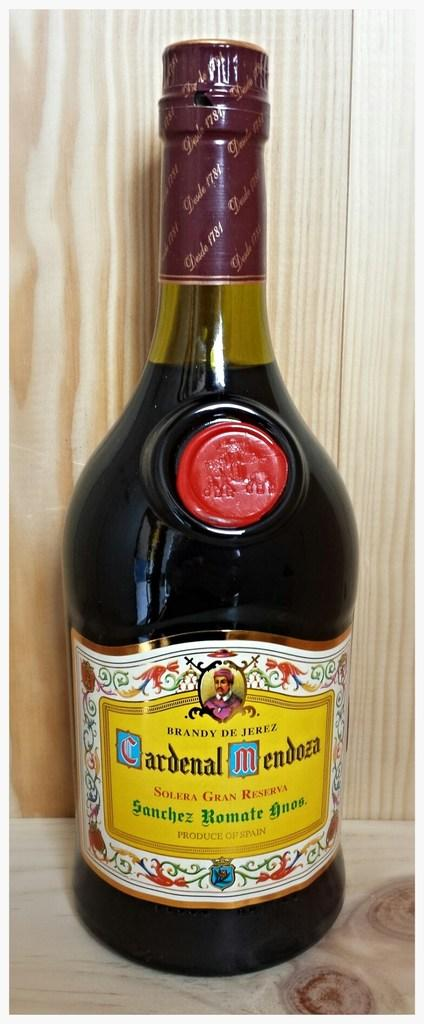What is the name of the bottle in the picture? The bottle is named Cardinal Mendosa. How is the bottle presented in the image? The bottle is beautifully packed. On what surface is the bottle placed? The bottle is placed on a wooden table. What type of crib is visible in the image? There is no crib present in the image. What nation is represented by the bottle in the image? The image does not provide information about the nation represented by the bottle. 